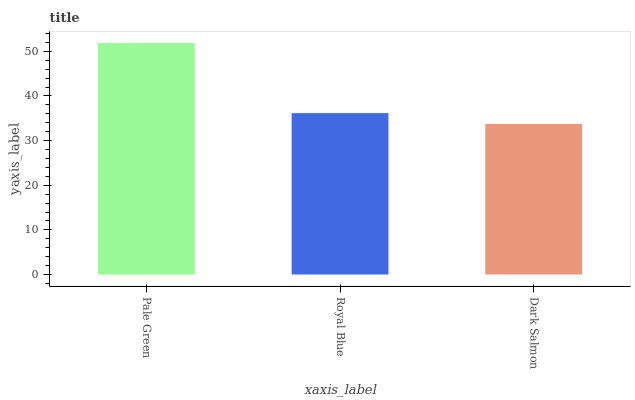Is Dark Salmon the minimum?
Answer yes or no. Yes. Is Pale Green the maximum?
Answer yes or no. Yes. Is Royal Blue the minimum?
Answer yes or no. No. Is Royal Blue the maximum?
Answer yes or no. No. Is Pale Green greater than Royal Blue?
Answer yes or no. Yes. Is Royal Blue less than Pale Green?
Answer yes or no. Yes. Is Royal Blue greater than Pale Green?
Answer yes or no. No. Is Pale Green less than Royal Blue?
Answer yes or no. No. Is Royal Blue the high median?
Answer yes or no. Yes. Is Royal Blue the low median?
Answer yes or no. Yes. Is Dark Salmon the high median?
Answer yes or no. No. Is Dark Salmon the low median?
Answer yes or no. No. 